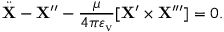<formula> <loc_0><loc_0><loc_500><loc_500>\ddot { X } - { X } ^ { \prime \prime } - { \frac { \mu } { 4 \pi \varepsilon _ { v } } } [ { X } ^ { \prime } \times { X } ^ { \prime \prime \prime } ] = 0 .</formula> 